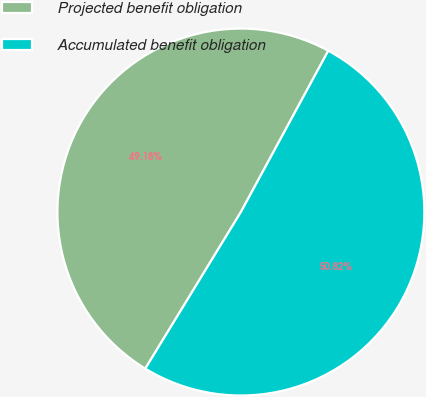Convert chart. <chart><loc_0><loc_0><loc_500><loc_500><pie_chart><fcel>Projected benefit obligation<fcel>Accumulated benefit obligation<nl><fcel>49.18%<fcel>50.82%<nl></chart> 